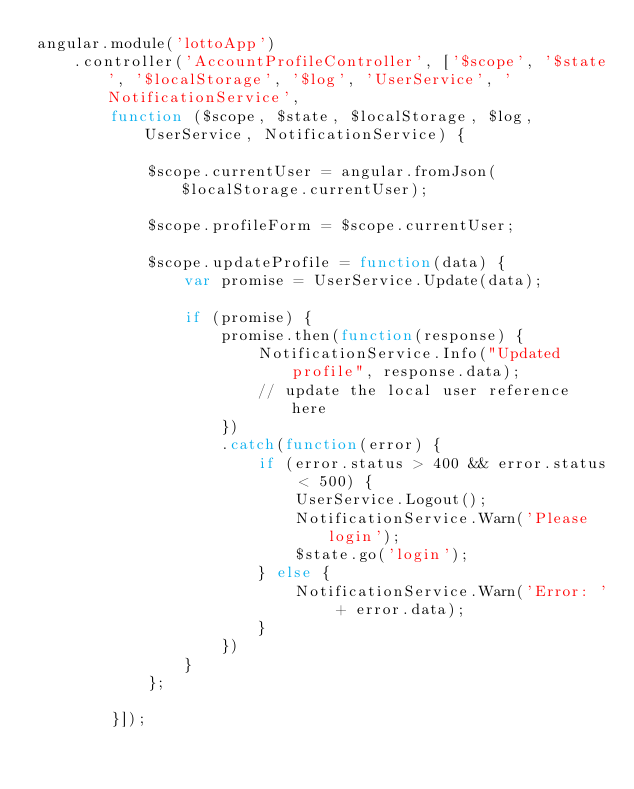Convert code to text. <code><loc_0><loc_0><loc_500><loc_500><_JavaScript_>angular.module('lottoApp')
    .controller('AccountProfileController', ['$scope', '$state', '$localStorage', '$log', 'UserService', 'NotificationService',
        function ($scope, $state, $localStorage, $log, UserService, NotificationService) {

            $scope.currentUser = angular.fromJson($localStorage.currentUser);

            $scope.profileForm = $scope.currentUser;

            $scope.updateProfile = function(data) {
                var promise = UserService.Update(data);

                if (promise) {
                    promise.then(function(response) {
                        NotificationService.Info("Updated profile", response.data);
                        // update the local user reference here
                    })
                    .catch(function(error) {
                        if (error.status > 400 && error.status < 500) {
                            UserService.Logout();
                            NotificationService.Warn('Please login');
                            $state.go('login');
                        } else {
                            NotificationService.Warn('Error: ' + error.data);
                        }
                    })
                }
            };

        }]);</code> 